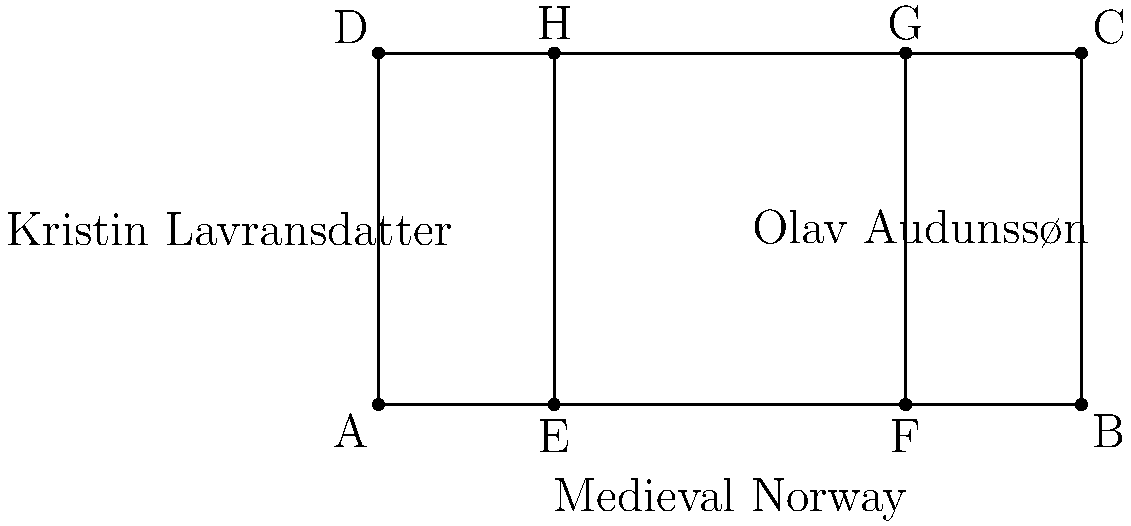In the diagram, the rectangle ABCD represents Sigrid Undset's literary landscape. The parallel lines EH and FG represent the parallel narratives in her major works, "Kristin Lavransdatter" and "Olav Audunssøn". If the width of the rectangle is 6 units and its height is 3 units, what is the ratio of the areas of the three regions formed by these parallel lines? To solve this problem, we need to follow these steps:

1. Recognize that the parallel lines divide the rectangle into three regions.

2. Calculate the width of each region:
   - The distance between A and E is 1.5 units
   - The distance between E and F is 3 units
   - The distance between F and B is 1.5 units

3. Calculate the area of each region:
   - Left region (Kristin Lavransdatter): $1.5 \times 3 = 4.5$ square units
   - Middle region (space between narratives): $3 \times 3 = 9$ square units
   - Right region (Olav Audunssøn): $1.5 \times 3 = 4.5$ square units

4. Express the ratio of these areas:
   $4.5 : 9 : 4.5$

5. Simplify the ratio by dividing all terms by their greatest common divisor (4.5):
   $1 : 2 : 1$

This ratio reflects Undset's balanced approach to her two major works, with equal space given to each narrative, separated by a larger space representing the historical and cultural context of medieval Norway that connects them.
Answer: $1:2:1$ 